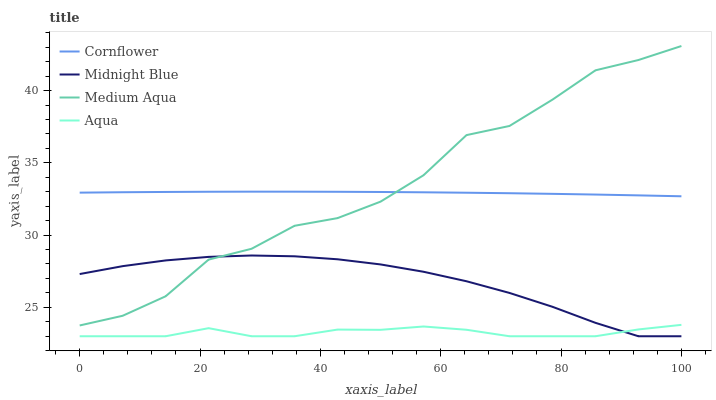Does Aqua have the minimum area under the curve?
Answer yes or no. Yes. Does Medium Aqua have the maximum area under the curve?
Answer yes or no. Yes. Does Cornflower have the minimum area under the curve?
Answer yes or no. No. Does Cornflower have the maximum area under the curve?
Answer yes or no. No. Is Cornflower the smoothest?
Answer yes or no. Yes. Is Medium Aqua the roughest?
Answer yes or no. Yes. Is Medium Aqua the smoothest?
Answer yes or no. No. Is Cornflower the roughest?
Answer yes or no. No. Does Aqua have the lowest value?
Answer yes or no. Yes. Does Medium Aqua have the lowest value?
Answer yes or no. No. Does Medium Aqua have the highest value?
Answer yes or no. Yes. Does Cornflower have the highest value?
Answer yes or no. No. Is Aqua less than Medium Aqua?
Answer yes or no. Yes. Is Medium Aqua greater than Aqua?
Answer yes or no. Yes. Does Aqua intersect Midnight Blue?
Answer yes or no. Yes. Is Aqua less than Midnight Blue?
Answer yes or no. No. Is Aqua greater than Midnight Blue?
Answer yes or no. No. Does Aqua intersect Medium Aqua?
Answer yes or no. No. 